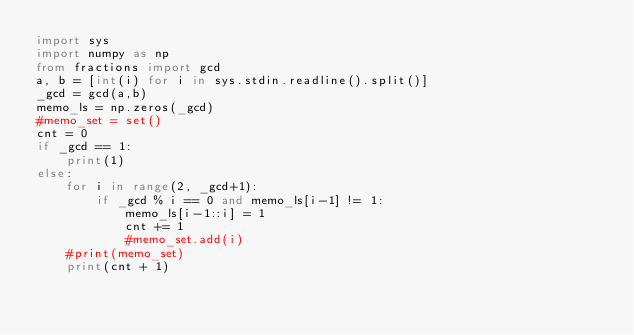Convert code to text. <code><loc_0><loc_0><loc_500><loc_500><_Python_>import sys
import numpy as np
from fractions import gcd
a, b = [int(i) for i in sys.stdin.readline().split()]
_gcd = gcd(a,b)
memo_ls = np.zeros(_gcd)
#memo_set = set()
cnt = 0
if _gcd == 1:
    print(1)
else:
    for i in range(2, _gcd+1):
        if _gcd % i == 0 and memo_ls[i-1] != 1:
            memo_ls[i-1::i] = 1
            cnt += 1
            #memo_set.add(i)
    #print(memo_set)
    print(cnt + 1)</code> 